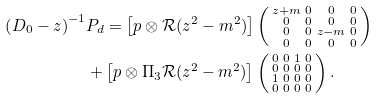Convert formula to latex. <formula><loc_0><loc_0><loc_500><loc_500>\left ( D _ { 0 } - z \right ) ^ { - 1 } & P _ { d } = \left [ p \otimes \mathcal { R } ( z ^ { 2 } - m ^ { 2 } ) \right ] \left ( \begin{smallmatrix} z + m & 0 & 0 & 0 \\ 0 & 0 & 0 & 0 \\ 0 & 0 & z - m & 0 \\ 0 & 0 & 0 & 0 \end{smallmatrix} \right ) \\ & + \left [ p \otimes \Pi _ { 3 } \mathcal { R } ( z ^ { 2 } - m ^ { 2 } ) \right ] \left ( \begin{smallmatrix} 0 & 0 & 1 & 0 \\ 0 & 0 & 0 & 0 \\ 1 & 0 & 0 & 0 \\ 0 & 0 & 0 & 0 \end{smallmatrix} \right ) .</formula> 